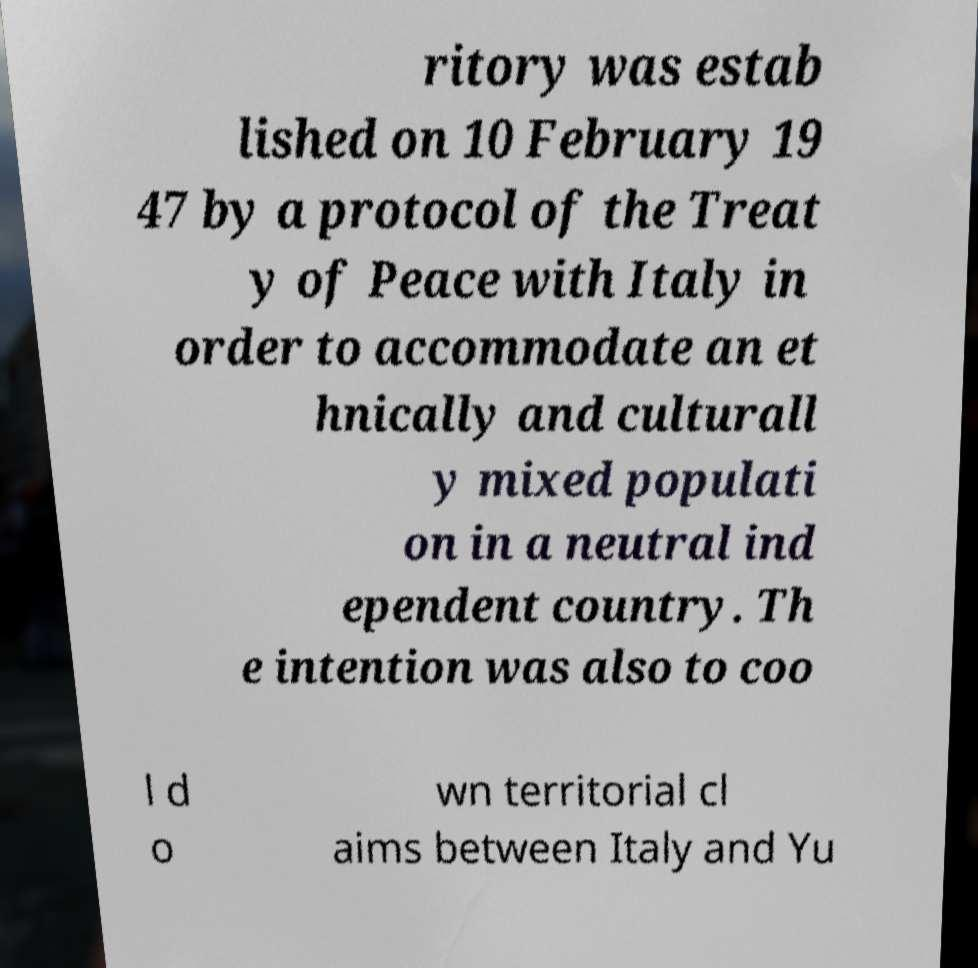Please read and relay the text visible in this image. What does it say? ritory was estab lished on 10 February 19 47 by a protocol of the Treat y of Peace with Italy in order to accommodate an et hnically and culturall y mixed populati on in a neutral ind ependent country. Th e intention was also to coo l d o wn territorial cl aims between Italy and Yu 